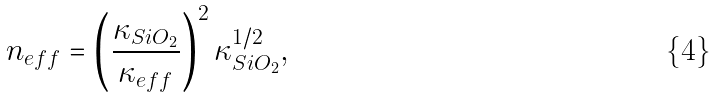<formula> <loc_0><loc_0><loc_500><loc_500>n _ { e f f } = \left ( \frac { \kappa _ { S i O _ { 2 } } } { \kappa _ { e f f } } \right ) ^ { 2 } \kappa _ { S i O _ { 2 } } ^ { 1 / 2 } ,</formula> 